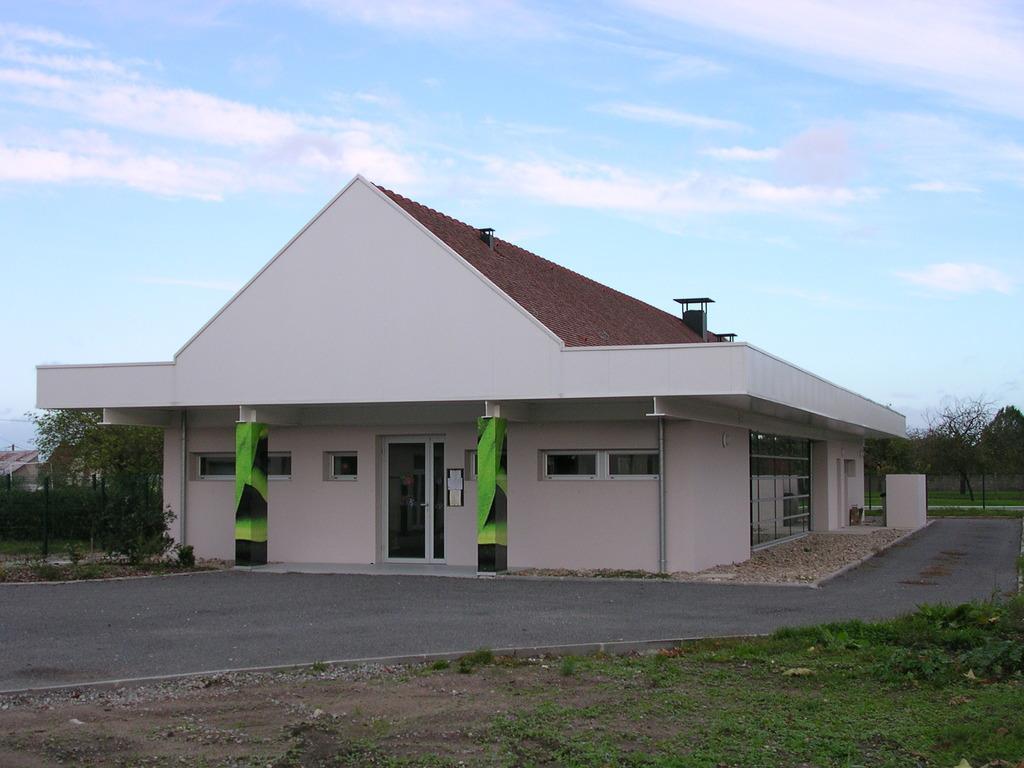How would you summarize this image in a sentence or two? This picture shows a buildings and we see trees and grass on the ground and we see a blue cloudy sky. 